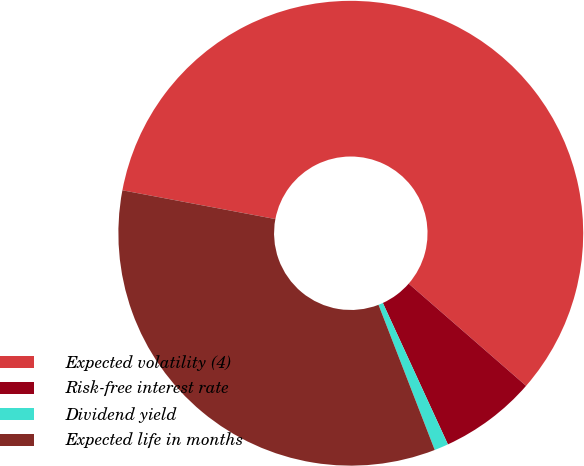Convert chart to OTSL. <chart><loc_0><loc_0><loc_500><loc_500><pie_chart><fcel>Expected volatility (4)<fcel>Risk-free interest rate<fcel>Dividend yield<fcel>Expected life in months<nl><fcel>58.44%<fcel>6.74%<fcel>0.98%<fcel>33.84%<nl></chart> 